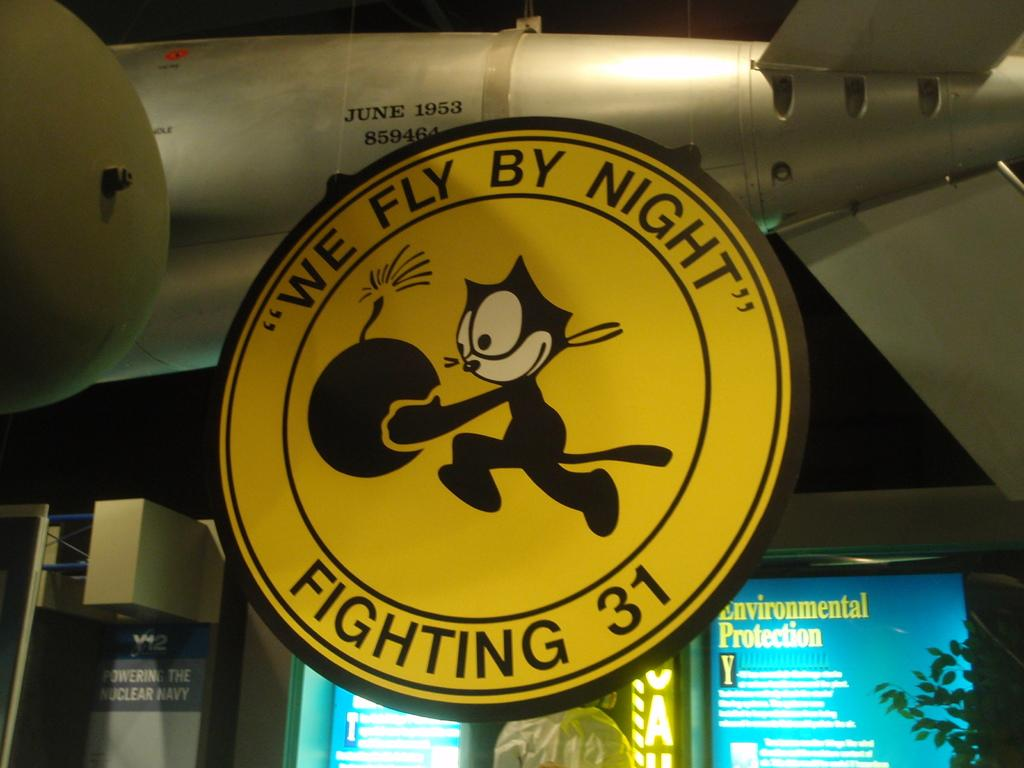Provide a one-sentence caption for the provided image. A sign with a cartoon cat holding a bomb that says "We Fly By Night" and "Fighting 31". 